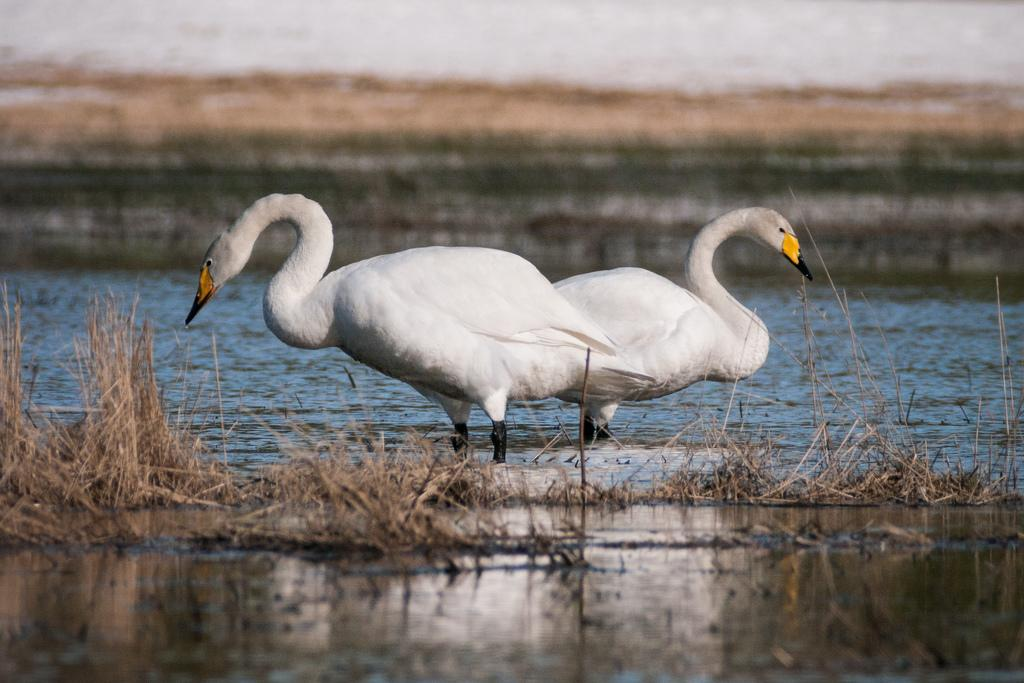What type of animals can be seen in the image? Birds can be seen in the water. What type of vegetation is present in the image? There is dry grass in the image. Can you describe the background of the image? The background of the image is not clear. What type of base can be seen supporting the underwear in the image? There is no base or underwear present in the image; it features birds in the water and dry grass. How many knots are visible in the image? There are no knots visible in the image. 